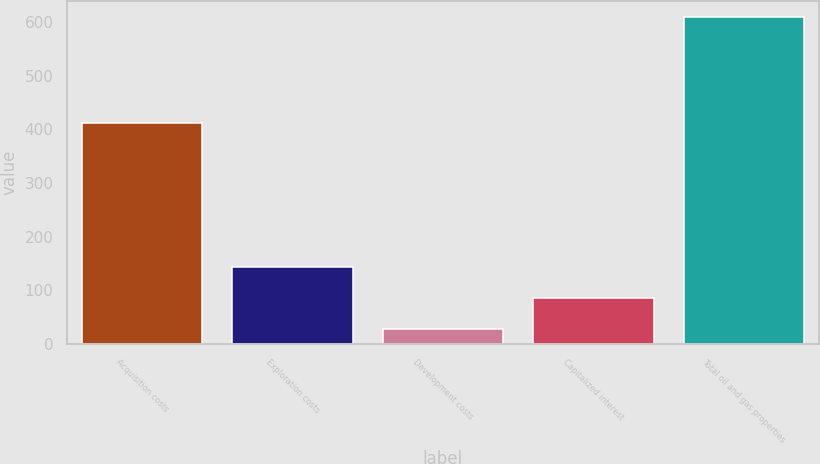Convert chart to OTSL. <chart><loc_0><loc_0><loc_500><loc_500><bar_chart><fcel>Acquisition costs<fcel>Exploration costs<fcel>Development costs<fcel>Capitalized interest<fcel>Total oil and gas properties<nl><fcel>412<fcel>144.2<fcel>28<fcel>86.1<fcel>609<nl></chart> 